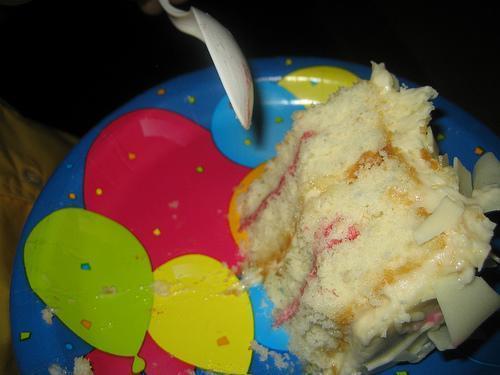How many pieces of cake can be seen?
Give a very brief answer. 1. How many colors are on the plate?
Give a very brief answer. 5. How many pieces of cake are on the plate?
Give a very brief answer. 1. How many green balloons are on the plte?
Give a very brief answer. 1. 